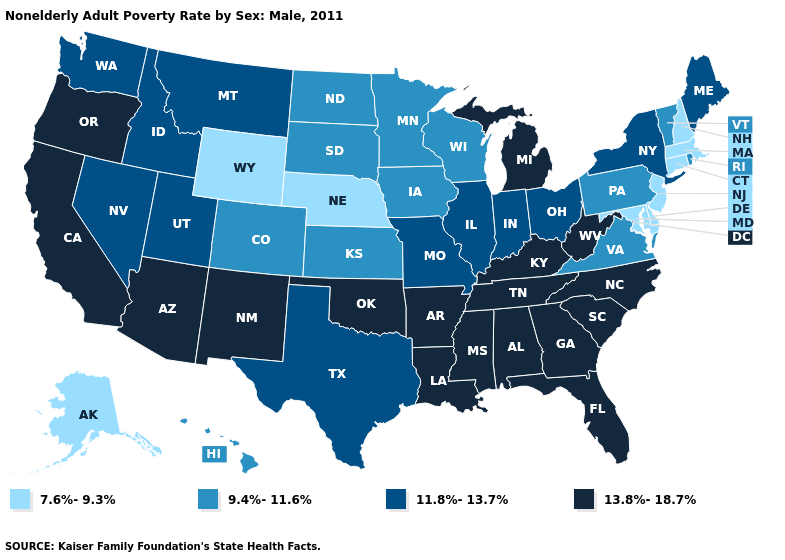What is the highest value in the MidWest ?
Keep it brief. 13.8%-18.7%. Which states hav the highest value in the West?
Write a very short answer. Arizona, California, New Mexico, Oregon. Among the states that border Georgia , which have the highest value?
Quick response, please. Alabama, Florida, North Carolina, South Carolina, Tennessee. Does Utah have the same value as Montana?
Give a very brief answer. Yes. What is the value of Maryland?
Give a very brief answer. 7.6%-9.3%. Name the states that have a value in the range 11.8%-13.7%?
Give a very brief answer. Idaho, Illinois, Indiana, Maine, Missouri, Montana, Nevada, New York, Ohio, Texas, Utah, Washington. Name the states that have a value in the range 7.6%-9.3%?
Write a very short answer. Alaska, Connecticut, Delaware, Maryland, Massachusetts, Nebraska, New Hampshire, New Jersey, Wyoming. Name the states that have a value in the range 7.6%-9.3%?
Quick response, please. Alaska, Connecticut, Delaware, Maryland, Massachusetts, Nebraska, New Hampshire, New Jersey, Wyoming. Which states have the lowest value in the USA?
Answer briefly. Alaska, Connecticut, Delaware, Maryland, Massachusetts, Nebraska, New Hampshire, New Jersey, Wyoming. What is the highest value in the MidWest ?
Short answer required. 13.8%-18.7%. Does Oklahoma have the highest value in the South?
Write a very short answer. Yes. What is the value of New Mexico?
Write a very short answer. 13.8%-18.7%. What is the value of Vermont?
Give a very brief answer. 9.4%-11.6%. Does Kansas have the same value as West Virginia?
Write a very short answer. No. Which states have the lowest value in the Northeast?
Write a very short answer. Connecticut, Massachusetts, New Hampshire, New Jersey. 